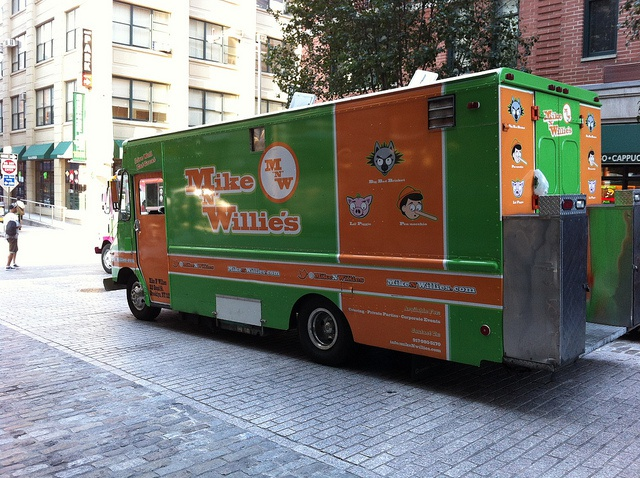Describe the objects in this image and their specific colors. I can see truck in white, darkgreen, maroon, black, and gray tones, people in white, gray, darkgray, and black tones, backpack in white, gray, and black tones, and people in white, ivory, gray, and darkgray tones in this image. 